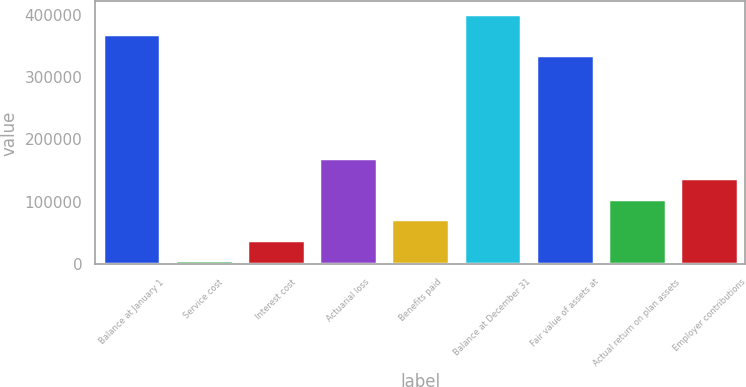Convert chart. <chart><loc_0><loc_0><loc_500><loc_500><bar_chart><fcel>Balance at January 1<fcel>Service cost<fcel>Interest cost<fcel>Actuarial loss<fcel>Benefits paid<fcel>Balance at December 31<fcel>Fair value of assets at<fcel>Actual return on plan assets<fcel>Employer contributions<nl><fcel>368293<fcel>6263<fcel>39174.8<fcel>170822<fcel>72086.6<fcel>401205<fcel>335381<fcel>104998<fcel>137910<nl></chart> 